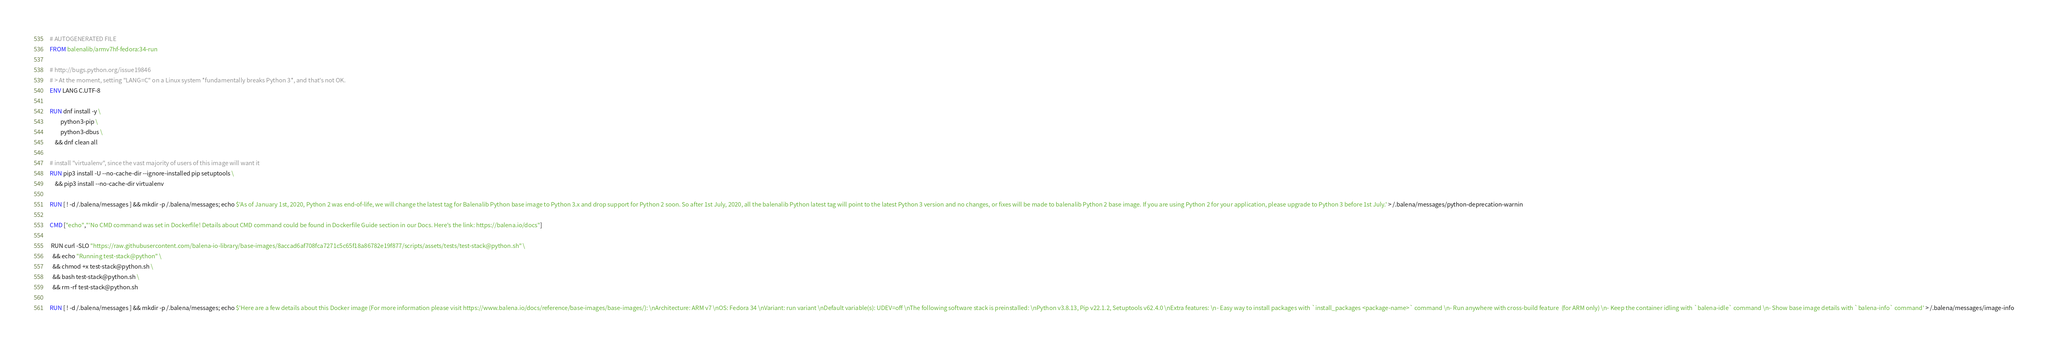<code> <loc_0><loc_0><loc_500><loc_500><_Dockerfile_># AUTOGENERATED FILE
FROM balenalib/armv7hf-fedora:34-run

# http://bugs.python.org/issue19846
# > At the moment, setting "LANG=C" on a Linux system *fundamentally breaks Python 3*, and that's not OK.
ENV LANG C.UTF-8

RUN dnf install -y \
		python3-pip \
		python3-dbus \
	&& dnf clean all

# install "virtualenv", since the vast majority of users of this image will want it
RUN pip3 install -U --no-cache-dir --ignore-installed pip setuptools \
	&& pip3 install --no-cache-dir virtualenv

RUN [ ! -d /.balena/messages ] && mkdir -p /.balena/messages; echo $'As of January 1st, 2020, Python 2 was end-of-life, we will change the latest tag for Balenalib Python base image to Python 3.x and drop support for Python 2 soon. So after 1st July, 2020, all the balenalib Python latest tag will point to the latest Python 3 version and no changes, or fixes will be made to balenalib Python 2 base image. If you are using Python 2 for your application, please upgrade to Python 3 before 1st July.' > /.balena/messages/python-deprecation-warnin

CMD ["echo","'No CMD command was set in Dockerfile! Details about CMD command could be found in Dockerfile Guide section in our Docs. Here's the link: https://balena.io/docs"]

 RUN curl -SLO "https://raw.githubusercontent.com/balena-io-library/base-images/8accad6af708fca7271c5c65f18a86782e19f877/scripts/assets/tests/test-stack@python.sh" \
  && echo "Running test-stack@python" \
  && chmod +x test-stack@python.sh \
  && bash test-stack@python.sh \
  && rm -rf test-stack@python.sh 

RUN [ ! -d /.balena/messages ] && mkdir -p /.balena/messages; echo $'Here are a few details about this Docker image (For more information please visit https://www.balena.io/docs/reference/base-images/base-images/): \nArchitecture: ARM v7 \nOS: Fedora 34 \nVariant: run variant \nDefault variable(s): UDEV=off \nThe following software stack is preinstalled: \nPython v3.8.13, Pip v22.1.2, Setuptools v62.4.0 \nExtra features: \n- Easy way to install packages with `install_packages <package-name>` command \n- Run anywhere with cross-build feature  (for ARM only) \n- Keep the container idling with `balena-idle` command \n- Show base image details with `balena-info` command' > /.balena/messages/image-info</code> 